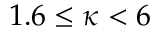Convert formula to latex. <formula><loc_0><loc_0><loc_500><loc_500>1 . 6 \leq \kappa < 6</formula> 